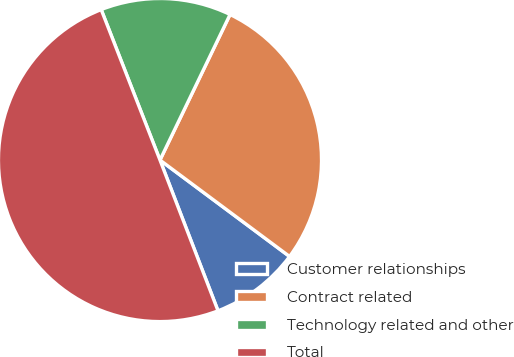Convert chart to OTSL. <chart><loc_0><loc_0><loc_500><loc_500><pie_chart><fcel>Customer relationships<fcel>Contract related<fcel>Technology related and other<fcel>Total<nl><fcel>8.97%<fcel>28.04%<fcel>13.07%<fcel>49.92%<nl></chart> 